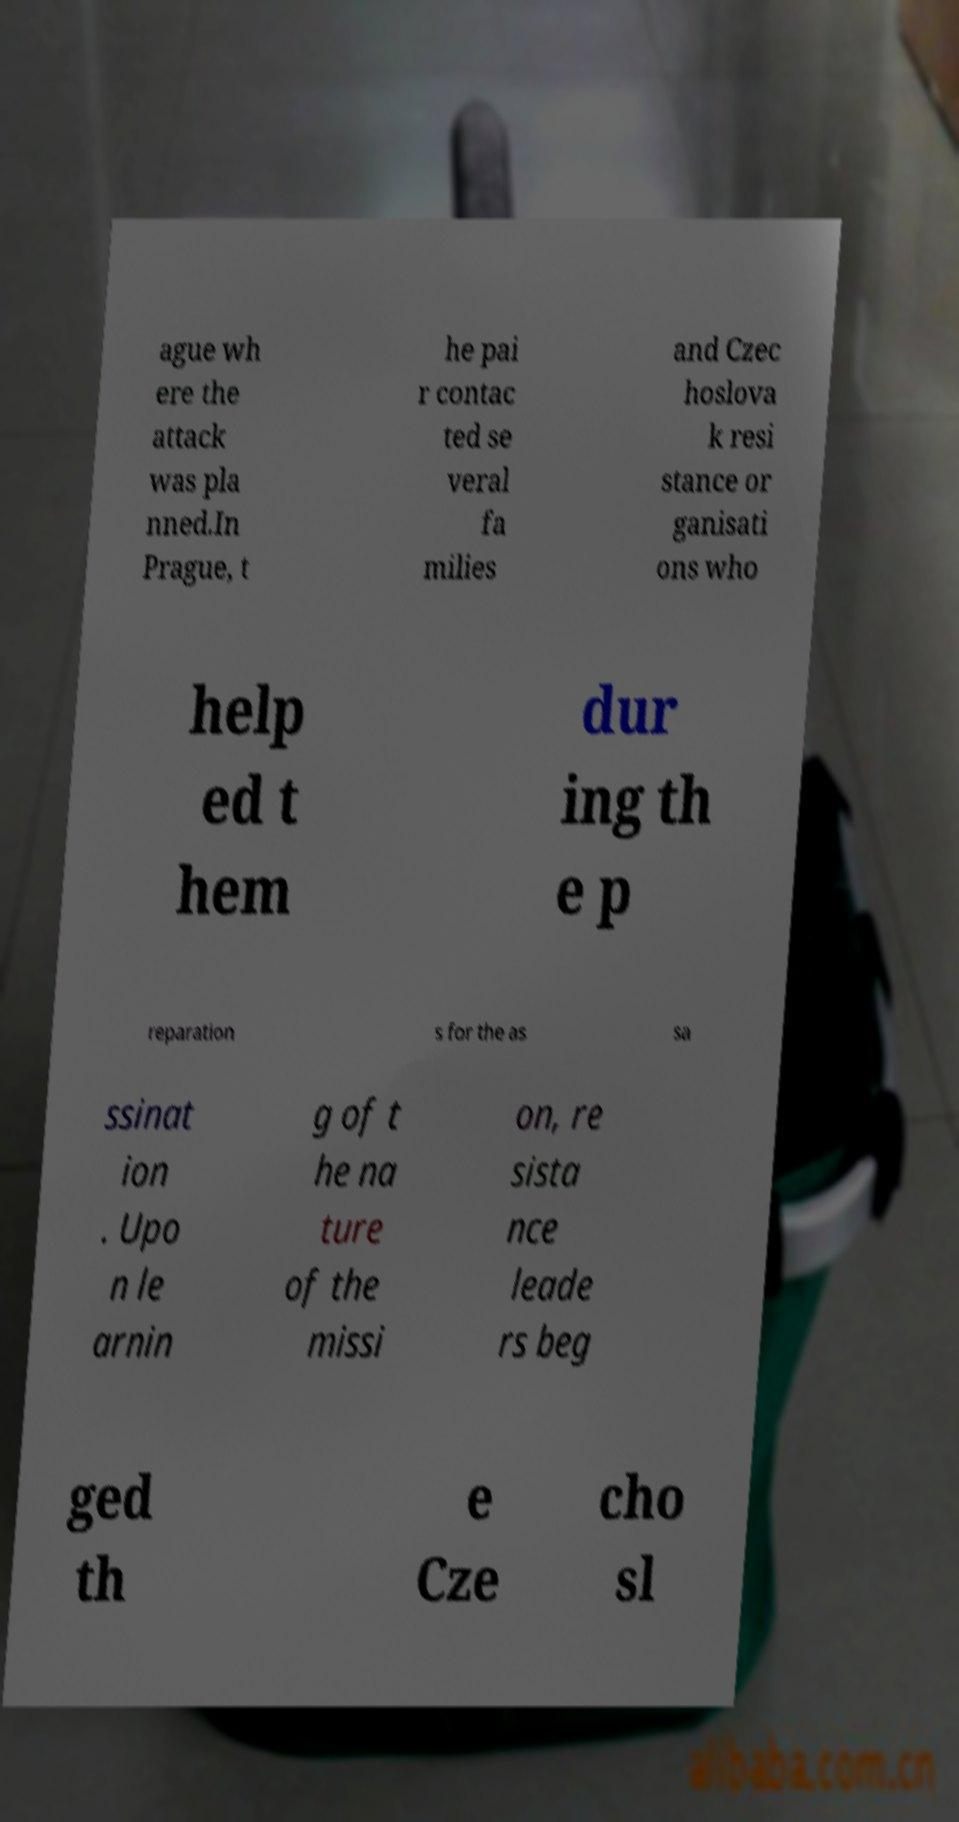Could you assist in decoding the text presented in this image and type it out clearly? ague wh ere the attack was pla nned.In Prague, t he pai r contac ted se veral fa milies and Czec hoslova k resi stance or ganisati ons who help ed t hem dur ing th e p reparation s for the as sa ssinat ion . Upo n le arnin g of t he na ture of the missi on, re sista nce leade rs beg ged th e Cze cho sl 